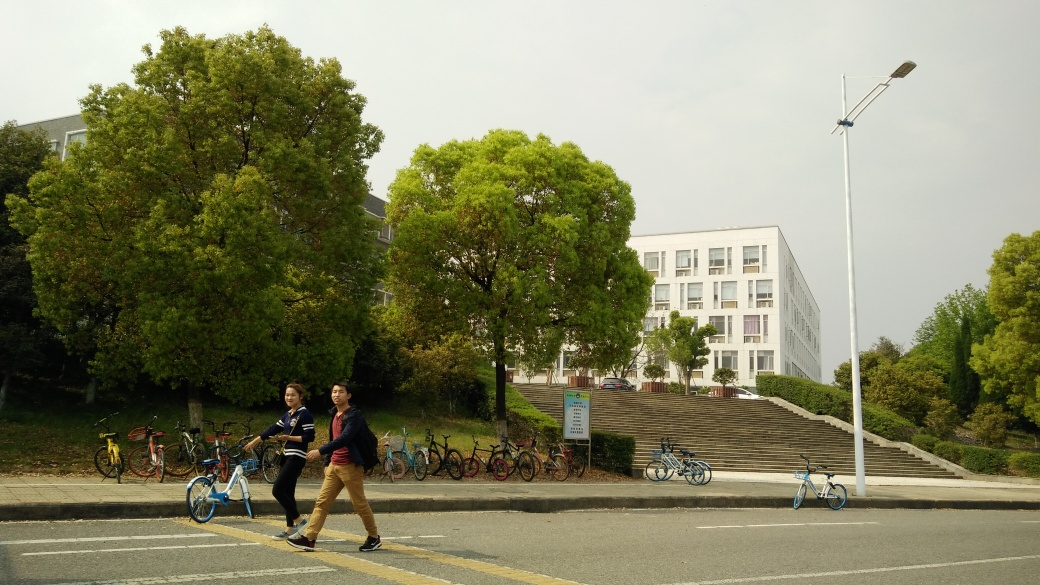What time of year does this image appear to represent based on the foliage and lighting? The foliage in the image, featuring fully leaved trees with lush greenery, suggests that it is taken during the spring or summer months. The overcast sky with soft, diffuse lighting indicates that it might be either early in the morning or later in the afternoon, but these conditions can also occur at any time during those seasons. 